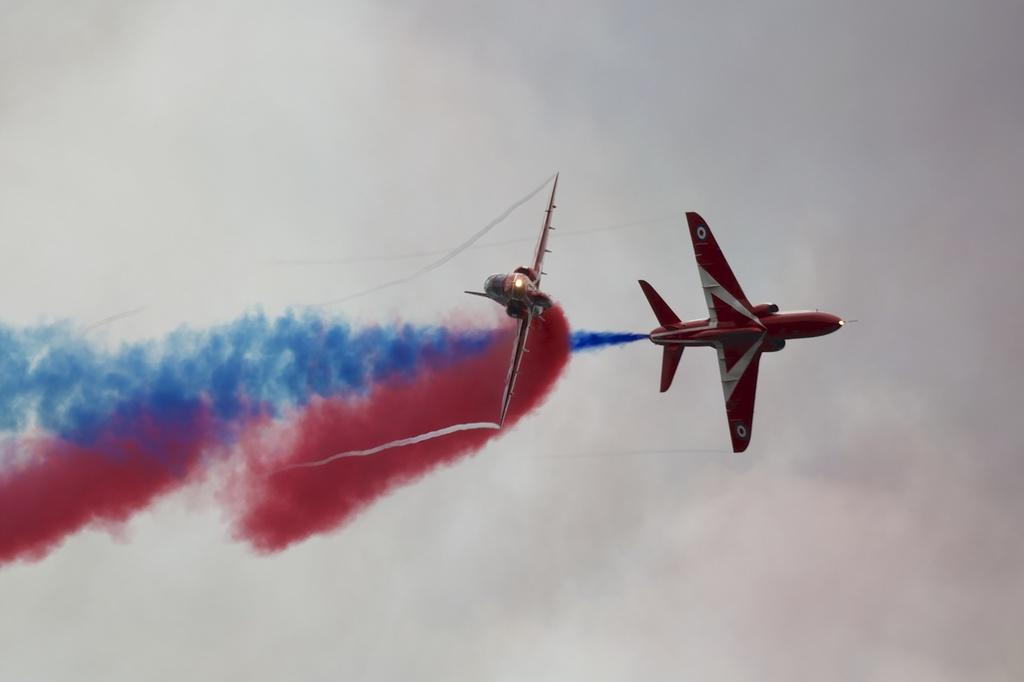What is the main subject of the image? The main subject of the image is two aircraft. What are the aircraft doing in the image? The aircraft are flying in the sky and releasing colored smoke. What type of substance is being used to clean the office floor in the image? There is no office or cleaning substance present in the image; it features two aircraft flying and releasing colored smoke. How many toes can be seen on the pilot's foot in the image? There is no pilot or foot visible in the image; it only shows two aircraft flying and releasing colored smoke. 